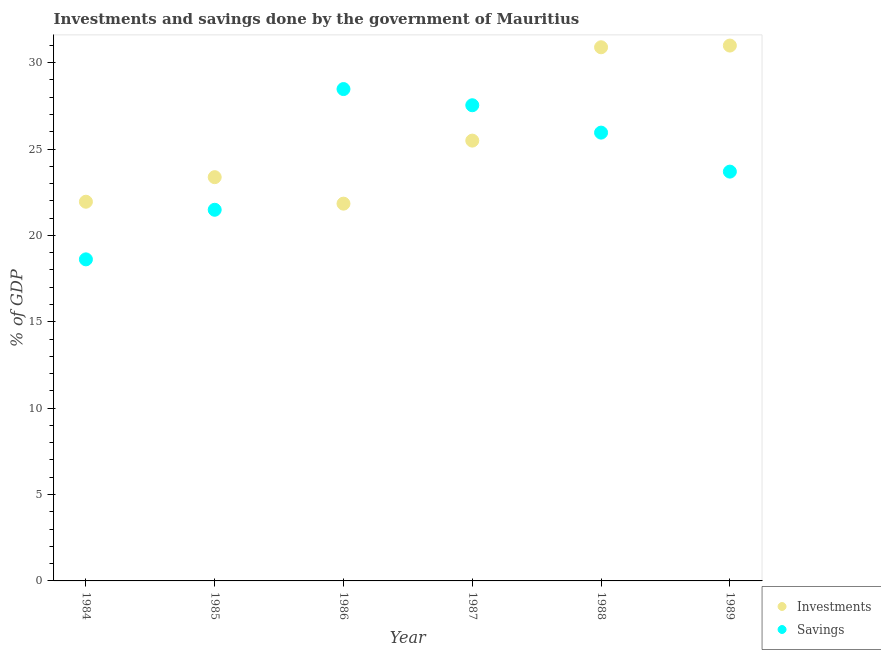What is the investments of government in 1989?
Your response must be concise. 30.99. Across all years, what is the maximum savings of government?
Your answer should be compact. 28.47. Across all years, what is the minimum investments of government?
Make the answer very short. 21.84. In which year was the investments of government minimum?
Your answer should be very brief. 1986. What is the total investments of government in the graph?
Your answer should be compact. 154.52. What is the difference between the savings of government in 1986 and that in 1988?
Offer a very short reply. 2.52. What is the difference between the savings of government in 1987 and the investments of government in 1986?
Provide a short and direct response. 5.7. What is the average savings of government per year?
Provide a short and direct response. 24.29. In the year 1987, what is the difference between the savings of government and investments of government?
Give a very brief answer. 2.05. In how many years, is the savings of government greater than 1 %?
Your response must be concise. 6. What is the ratio of the investments of government in 1988 to that in 1989?
Offer a terse response. 1. Is the investments of government in 1984 less than that in 1986?
Make the answer very short. No. Is the difference between the savings of government in 1984 and 1989 greater than the difference between the investments of government in 1984 and 1989?
Your answer should be very brief. Yes. What is the difference between the highest and the second highest investments of government?
Ensure brevity in your answer.  0.1. What is the difference between the highest and the lowest savings of government?
Offer a terse response. 9.86. Does the investments of government monotonically increase over the years?
Your response must be concise. No. How many years are there in the graph?
Provide a succinct answer. 6. What is the difference between two consecutive major ticks on the Y-axis?
Give a very brief answer. 5. Does the graph contain any zero values?
Your answer should be very brief. No. Does the graph contain grids?
Your response must be concise. No. How are the legend labels stacked?
Offer a terse response. Vertical. What is the title of the graph?
Your answer should be compact. Investments and savings done by the government of Mauritius. Does "Public credit registry" appear as one of the legend labels in the graph?
Make the answer very short. No. What is the label or title of the Y-axis?
Your answer should be very brief. % of GDP. What is the % of GDP of Investments in 1984?
Give a very brief answer. 21.95. What is the % of GDP in Savings in 1984?
Ensure brevity in your answer.  18.61. What is the % of GDP of Investments in 1985?
Keep it short and to the point. 23.37. What is the % of GDP in Savings in 1985?
Your answer should be very brief. 21.48. What is the % of GDP in Investments in 1986?
Provide a short and direct response. 21.84. What is the % of GDP in Savings in 1986?
Your answer should be very brief. 28.47. What is the % of GDP of Investments in 1987?
Provide a succinct answer. 25.49. What is the % of GDP in Savings in 1987?
Keep it short and to the point. 27.53. What is the % of GDP of Investments in 1988?
Give a very brief answer. 30.89. What is the % of GDP in Savings in 1988?
Offer a terse response. 25.95. What is the % of GDP in Investments in 1989?
Make the answer very short. 30.99. What is the % of GDP in Savings in 1989?
Offer a very short reply. 23.69. Across all years, what is the maximum % of GDP of Investments?
Provide a succinct answer. 30.99. Across all years, what is the maximum % of GDP in Savings?
Your response must be concise. 28.47. Across all years, what is the minimum % of GDP in Investments?
Your answer should be compact. 21.84. Across all years, what is the minimum % of GDP in Savings?
Make the answer very short. 18.61. What is the total % of GDP in Investments in the graph?
Your answer should be very brief. 154.52. What is the total % of GDP of Savings in the graph?
Ensure brevity in your answer.  145.74. What is the difference between the % of GDP of Investments in 1984 and that in 1985?
Give a very brief answer. -1.42. What is the difference between the % of GDP of Savings in 1984 and that in 1985?
Your response must be concise. -2.87. What is the difference between the % of GDP in Investments in 1984 and that in 1986?
Your answer should be compact. 0.11. What is the difference between the % of GDP in Savings in 1984 and that in 1986?
Give a very brief answer. -9.86. What is the difference between the % of GDP in Investments in 1984 and that in 1987?
Provide a short and direct response. -3.54. What is the difference between the % of GDP of Savings in 1984 and that in 1987?
Provide a short and direct response. -8.92. What is the difference between the % of GDP of Investments in 1984 and that in 1988?
Your answer should be compact. -8.94. What is the difference between the % of GDP in Savings in 1984 and that in 1988?
Ensure brevity in your answer.  -7.34. What is the difference between the % of GDP in Investments in 1984 and that in 1989?
Give a very brief answer. -9.04. What is the difference between the % of GDP in Savings in 1984 and that in 1989?
Offer a very short reply. -5.08. What is the difference between the % of GDP in Investments in 1985 and that in 1986?
Provide a short and direct response. 1.53. What is the difference between the % of GDP in Savings in 1985 and that in 1986?
Keep it short and to the point. -6.99. What is the difference between the % of GDP of Investments in 1985 and that in 1987?
Offer a very short reply. -2.12. What is the difference between the % of GDP in Savings in 1985 and that in 1987?
Your response must be concise. -6.05. What is the difference between the % of GDP of Investments in 1985 and that in 1988?
Offer a terse response. -7.52. What is the difference between the % of GDP of Savings in 1985 and that in 1988?
Provide a succinct answer. -4.47. What is the difference between the % of GDP in Investments in 1985 and that in 1989?
Provide a succinct answer. -7.62. What is the difference between the % of GDP of Savings in 1985 and that in 1989?
Provide a succinct answer. -2.21. What is the difference between the % of GDP in Investments in 1986 and that in 1987?
Your answer should be compact. -3.65. What is the difference between the % of GDP of Savings in 1986 and that in 1987?
Offer a very short reply. 0.94. What is the difference between the % of GDP of Investments in 1986 and that in 1988?
Make the answer very short. -9.05. What is the difference between the % of GDP of Savings in 1986 and that in 1988?
Offer a very short reply. 2.52. What is the difference between the % of GDP in Investments in 1986 and that in 1989?
Your answer should be compact. -9.15. What is the difference between the % of GDP in Savings in 1986 and that in 1989?
Ensure brevity in your answer.  4.78. What is the difference between the % of GDP of Investments in 1987 and that in 1988?
Provide a short and direct response. -5.4. What is the difference between the % of GDP of Savings in 1987 and that in 1988?
Your answer should be very brief. 1.58. What is the difference between the % of GDP of Investments in 1987 and that in 1989?
Give a very brief answer. -5.5. What is the difference between the % of GDP of Savings in 1987 and that in 1989?
Offer a very short reply. 3.84. What is the difference between the % of GDP of Investments in 1988 and that in 1989?
Your response must be concise. -0.1. What is the difference between the % of GDP in Savings in 1988 and that in 1989?
Ensure brevity in your answer.  2.26. What is the difference between the % of GDP of Investments in 1984 and the % of GDP of Savings in 1985?
Ensure brevity in your answer.  0.47. What is the difference between the % of GDP of Investments in 1984 and the % of GDP of Savings in 1986?
Ensure brevity in your answer.  -6.52. What is the difference between the % of GDP of Investments in 1984 and the % of GDP of Savings in 1987?
Keep it short and to the point. -5.58. What is the difference between the % of GDP in Investments in 1984 and the % of GDP in Savings in 1988?
Provide a short and direct response. -4. What is the difference between the % of GDP of Investments in 1984 and the % of GDP of Savings in 1989?
Provide a short and direct response. -1.74. What is the difference between the % of GDP in Investments in 1985 and the % of GDP in Savings in 1986?
Offer a terse response. -5.1. What is the difference between the % of GDP in Investments in 1985 and the % of GDP in Savings in 1987?
Keep it short and to the point. -4.16. What is the difference between the % of GDP of Investments in 1985 and the % of GDP of Savings in 1988?
Your answer should be compact. -2.58. What is the difference between the % of GDP of Investments in 1985 and the % of GDP of Savings in 1989?
Keep it short and to the point. -0.32. What is the difference between the % of GDP of Investments in 1986 and the % of GDP of Savings in 1987?
Offer a very short reply. -5.7. What is the difference between the % of GDP in Investments in 1986 and the % of GDP in Savings in 1988?
Offer a very short reply. -4.11. What is the difference between the % of GDP of Investments in 1986 and the % of GDP of Savings in 1989?
Make the answer very short. -1.85. What is the difference between the % of GDP in Investments in 1987 and the % of GDP in Savings in 1988?
Give a very brief answer. -0.46. What is the difference between the % of GDP in Investments in 1987 and the % of GDP in Savings in 1989?
Your response must be concise. 1.79. What is the difference between the % of GDP of Investments in 1988 and the % of GDP of Savings in 1989?
Your answer should be very brief. 7.2. What is the average % of GDP of Investments per year?
Your answer should be compact. 25.75. What is the average % of GDP of Savings per year?
Your response must be concise. 24.29. In the year 1984, what is the difference between the % of GDP in Investments and % of GDP in Savings?
Provide a short and direct response. 3.34. In the year 1985, what is the difference between the % of GDP of Investments and % of GDP of Savings?
Provide a succinct answer. 1.89. In the year 1986, what is the difference between the % of GDP in Investments and % of GDP in Savings?
Offer a very short reply. -6.63. In the year 1987, what is the difference between the % of GDP of Investments and % of GDP of Savings?
Provide a succinct answer. -2.05. In the year 1988, what is the difference between the % of GDP of Investments and % of GDP of Savings?
Ensure brevity in your answer.  4.94. In the year 1989, what is the difference between the % of GDP of Investments and % of GDP of Savings?
Offer a terse response. 7.3. What is the ratio of the % of GDP in Investments in 1984 to that in 1985?
Offer a very short reply. 0.94. What is the ratio of the % of GDP of Savings in 1984 to that in 1985?
Your response must be concise. 0.87. What is the ratio of the % of GDP in Savings in 1984 to that in 1986?
Provide a short and direct response. 0.65. What is the ratio of the % of GDP in Investments in 1984 to that in 1987?
Give a very brief answer. 0.86. What is the ratio of the % of GDP in Savings in 1984 to that in 1987?
Ensure brevity in your answer.  0.68. What is the ratio of the % of GDP of Investments in 1984 to that in 1988?
Your answer should be very brief. 0.71. What is the ratio of the % of GDP in Savings in 1984 to that in 1988?
Your response must be concise. 0.72. What is the ratio of the % of GDP in Investments in 1984 to that in 1989?
Offer a terse response. 0.71. What is the ratio of the % of GDP in Savings in 1984 to that in 1989?
Your answer should be very brief. 0.79. What is the ratio of the % of GDP of Investments in 1985 to that in 1986?
Your answer should be very brief. 1.07. What is the ratio of the % of GDP in Savings in 1985 to that in 1986?
Provide a succinct answer. 0.75. What is the ratio of the % of GDP in Investments in 1985 to that in 1987?
Provide a short and direct response. 0.92. What is the ratio of the % of GDP of Savings in 1985 to that in 1987?
Provide a short and direct response. 0.78. What is the ratio of the % of GDP of Investments in 1985 to that in 1988?
Keep it short and to the point. 0.76. What is the ratio of the % of GDP in Savings in 1985 to that in 1988?
Keep it short and to the point. 0.83. What is the ratio of the % of GDP in Investments in 1985 to that in 1989?
Offer a terse response. 0.75. What is the ratio of the % of GDP of Savings in 1985 to that in 1989?
Your response must be concise. 0.91. What is the ratio of the % of GDP in Investments in 1986 to that in 1987?
Offer a very short reply. 0.86. What is the ratio of the % of GDP of Savings in 1986 to that in 1987?
Offer a terse response. 1.03. What is the ratio of the % of GDP of Investments in 1986 to that in 1988?
Offer a very short reply. 0.71. What is the ratio of the % of GDP of Savings in 1986 to that in 1988?
Offer a terse response. 1.1. What is the ratio of the % of GDP in Investments in 1986 to that in 1989?
Offer a terse response. 0.7. What is the ratio of the % of GDP in Savings in 1986 to that in 1989?
Provide a succinct answer. 1.2. What is the ratio of the % of GDP of Investments in 1987 to that in 1988?
Make the answer very short. 0.83. What is the ratio of the % of GDP of Savings in 1987 to that in 1988?
Give a very brief answer. 1.06. What is the ratio of the % of GDP of Investments in 1987 to that in 1989?
Keep it short and to the point. 0.82. What is the ratio of the % of GDP in Savings in 1987 to that in 1989?
Give a very brief answer. 1.16. What is the ratio of the % of GDP in Savings in 1988 to that in 1989?
Give a very brief answer. 1.1. What is the difference between the highest and the second highest % of GDP of Investments?
Provide a succinct answer. 0.1. What is the difference between the highest and the second highest % of GDP in Savings?
Ensure brevity in your answer.  0.94. What is the difference between the highest and the lowest % of GDP of Investments?
Provide a short and direct response. 9.15. What is the difference between the highest and the lowest % of GDP of Savings?
Your answer should be very brief. 9.86. 